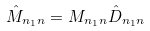<formula> <loc_0><loc_0><loc_500><loc_500>\hat { M } _ { n _ { 1 } n } = M _ { n _ { 1 } n } \hat { D } _ { n _ { 1 } n }</formula> 